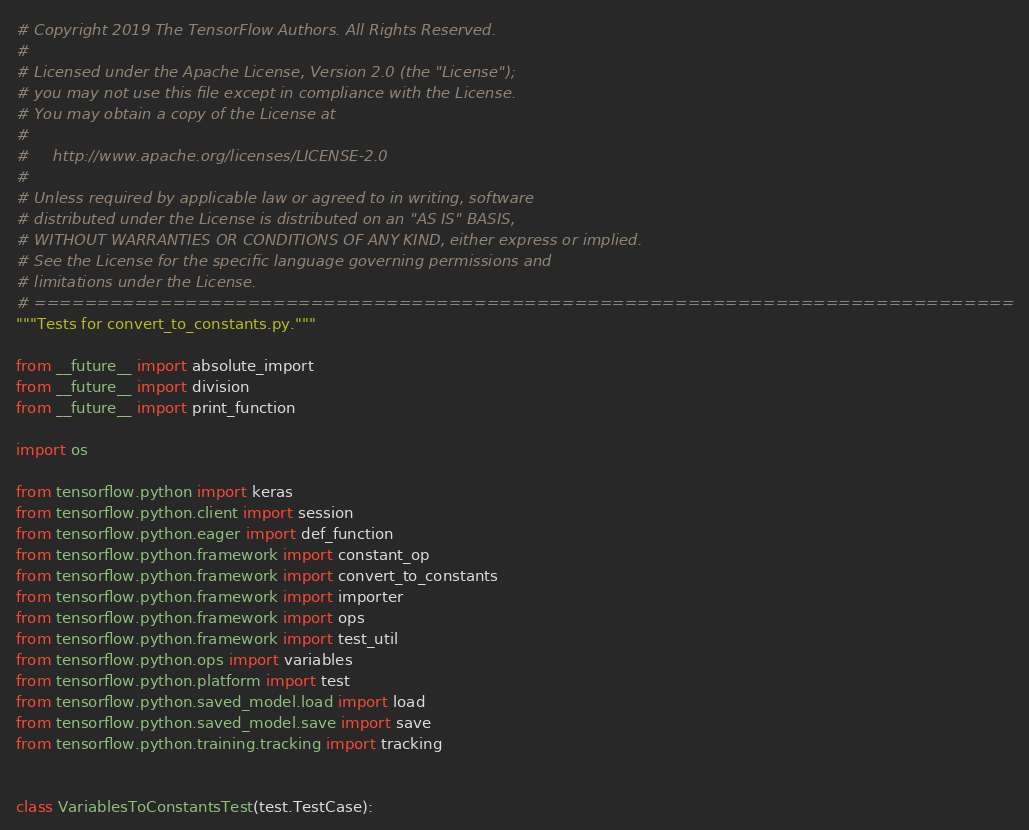<code> <loc_0><loc_0><loc_500><loc_500><_Python_># Copyright 2019 The TensorFlow Authors. All Rights Reserved.
#
# Licensed under the Apache License, Version 2.0 (the "License");
# you may not use this file except in compliance with the License.
# You may obtain a copy of the License at
#
#     http://www.apache.org/licenses/LICENSE-2.0
#
# Unless required by applicable law or agreed to in writing, software
# distributed under the License is distributed on an "AS IS" BASIS,
# WITHOUT WARRANTIES OR CONDITIONS OF ANY KIND, either express or implied.
# See the License for the specific language governing permissions and
# limitations under the License.
# ==============================================================================
"""Tests for convert_to_constants.py."""

from __future__ import absolute_import
from __future__ import division
from __future__ import print_function

import os

from tensorflow.python import keras
from tensorflow.python.client import session
from tensorflow.python.eager import def_function
from tensorflow.python.framework import constant_op
from tensorflow.python.framework import convert_to_constants
from tensorflow.python.framework import importer
from tensorflow.python.framework import ops
from tensorflow.python.framework import test_util
from tensorflow.python.ops import variables
from tensorflow.python.platform import test
from tensorflow.python.saved_model.load import load
from tensorflow.python.saved_model.save import save
from tensorflow.python.training.tracking import tracking


class VariablesToConstantsTest(test.TestCase):
</code> 